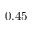<formula> <loc_0><loc_0><loc_500><loc_500>0 . 4 5</formula> 